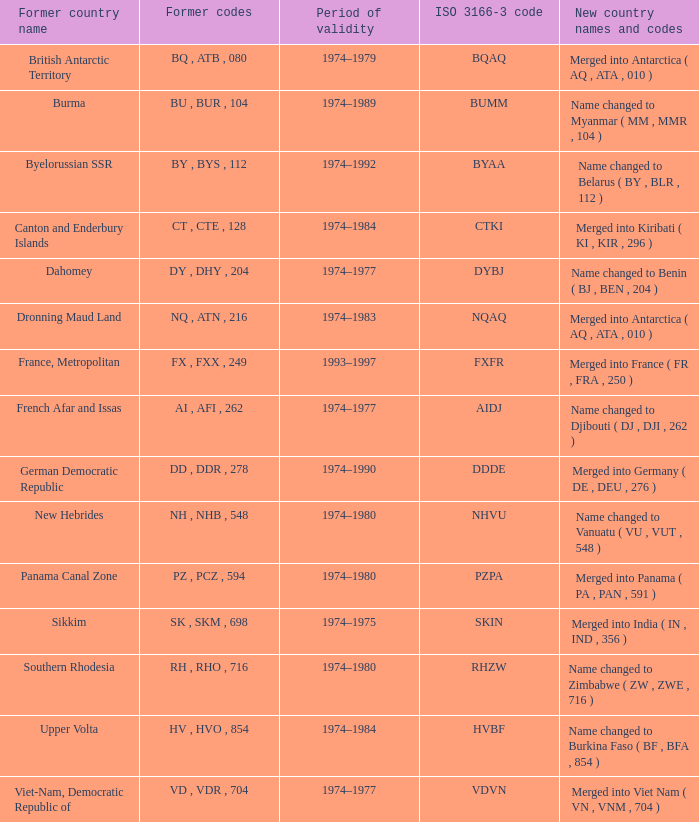Identify the complete length of validity for upper volta. 1.0. 